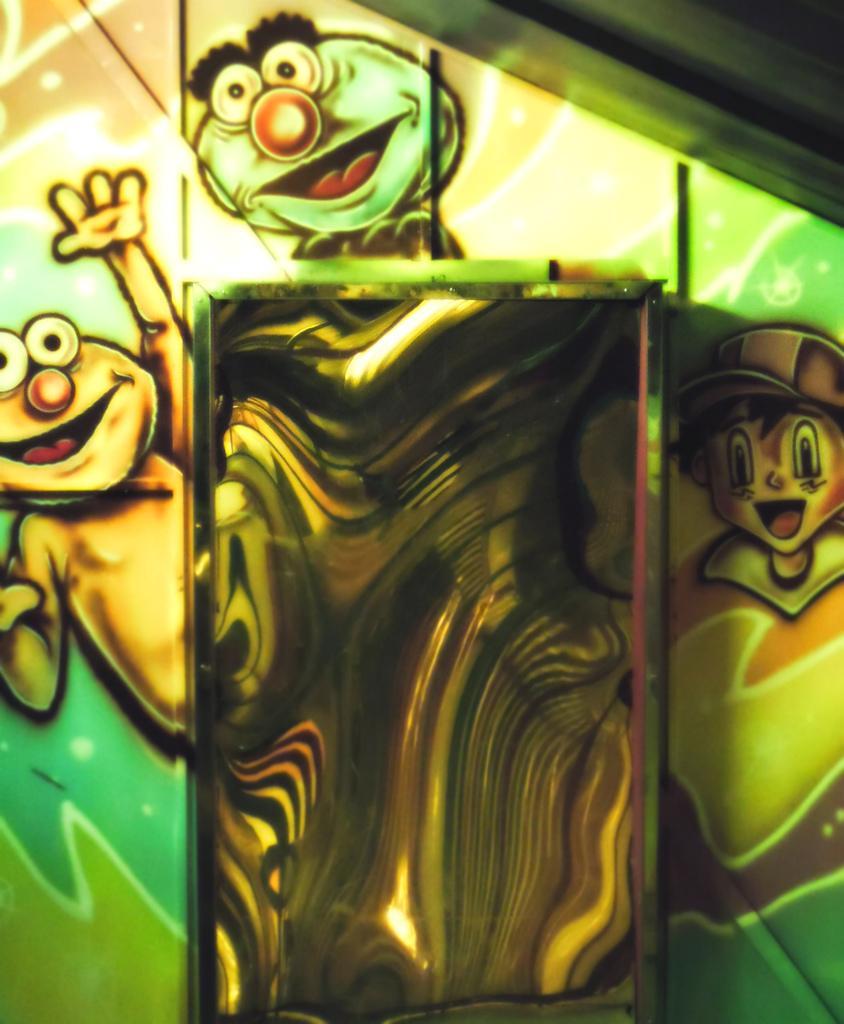In one or two sentences, can you explain what this image depicts? In this image I can see painting of cartoon characters on a surface. 